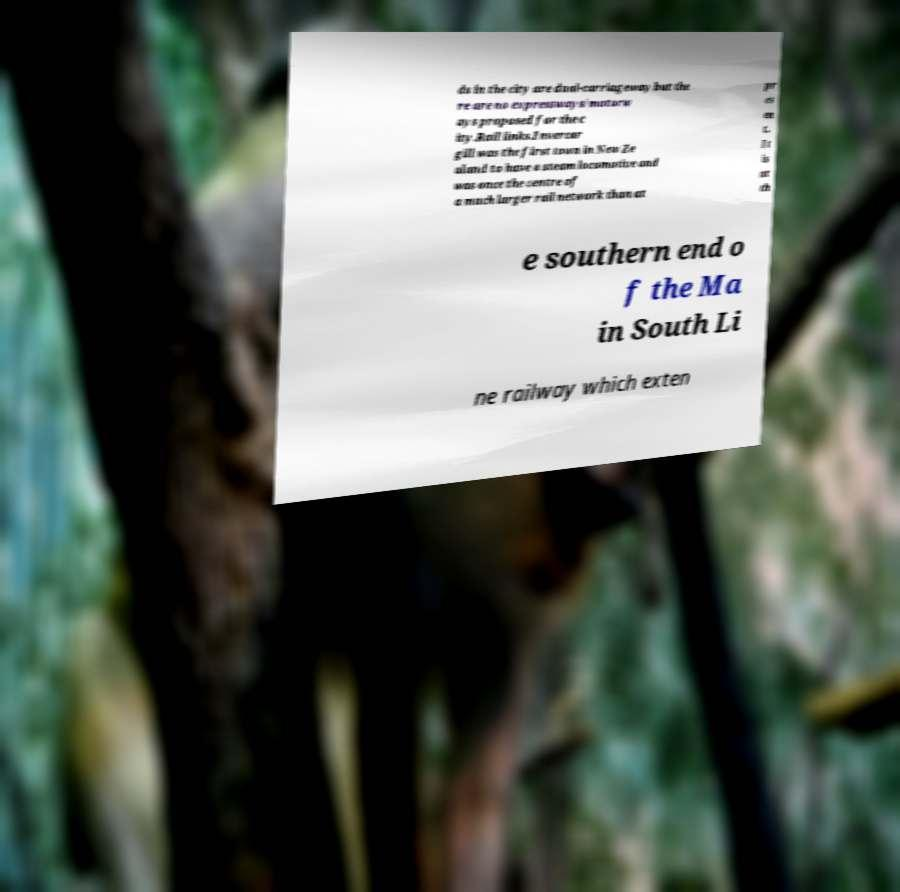Can you read and provide the text displayed in the image?This photo seems to have some interesting text. Can you extract and type it out for me? ds in the city are dual-carriageway but the re are no expressways/motorw ays proposed for the c ity.Rail links.Invercar gill was the first town in New Ze aland to have a steam locomotive and was once the centre of a much larger rail network than at pr es en t. It is at th e southern end o f the Ma in South Li ne railway which exten 